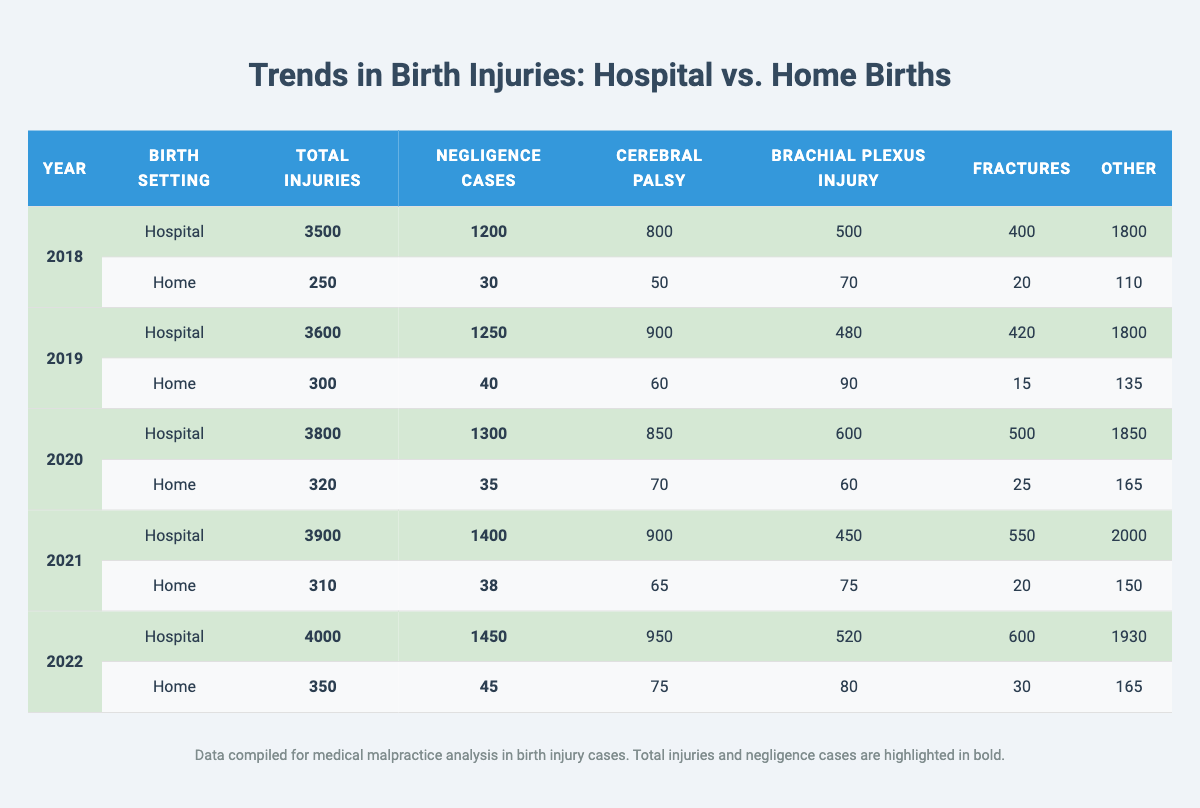What was the total number of injuries reported for hospital births in 2022? In the row for 2022 under the hospital column, the total injuries are bolded as 4000.
Answer: 4000 What is the difference in the number of negligence cases reported between hospital and home births in 2019? For 2019, hospital births had 1250 negligence cases and home births had 40. The difference is 1250 - 40 = 1210.
Answer: 1210 Which year had the highest number of reported total injuries for home births? Upon checking the home birth rows, the year with the most total injuries is 2022 with 350 injuries, which is bolded.
Answer: 2022 What is the average number of negligence cases reported for home births across all years? The negligence cases for home births are: 30 + 40 + 35 + 38 + 45 = 188. There are 5 years, so to find the average, we calculate 188/5 = 37.6 and round it to 38 for simplicity.
Answer: 38 Is the total number of injuries for hospital births consistently increasing each year from 2018 to 2022? Reviewing the total injuries for hospital births across these years: 3500, 3600, 3800, 3900, and 4000, we see they are all increasing.
Answer: Yes What percentage of total injuries in hospital births were related to cerebral palsy in 2020? In 2020, the total injuries for hospital births are 3800, and the cerebral palsy injuries are 850. The percentage is (850/3800)*100 = 22.37%.
Answer: 22.37% What was the trend in the number of brachial plexus injuries from 2018 to 2022 in hospital births? The brachial plexus injuries for hospital births show: 500 (2018), 480 (2019), 600 (2020), 450 (2021), and 520 (2022). This indicates a decrease from 2018 to 2019, an increase in 2020, a decrease in 2021, and an increase in 2022.
Answer: Fluctuating Which type of injury had the most cases in home births in 2021? In the home birth row for 2021, the types of injuries showed that brachial plexus injuries had 75, which is the highest compared to 65 (cerebral palsy), 20 (fractures), and 150 (other).
Answer: Brachial plexus injury By how much did the number of total injuries for hospital births increase from 2019 to 2020? The total injuries reported for hospital births were 3600 in 2019 and 3800 in 2020. The increase is 3800 - 3600 = 200.
Answer: 200 